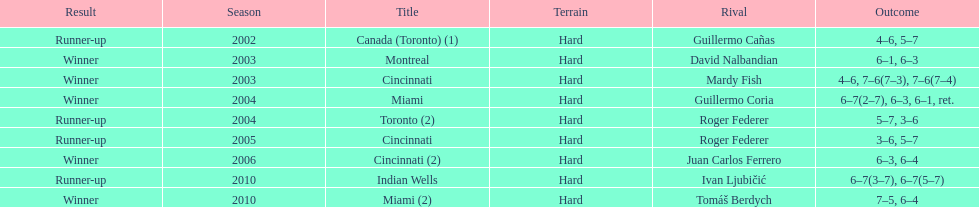How many times was the championship in miami? 2. Give me the full table as a dictionary. {'header': ['Result', 'Season', 'Title', 'Terrain', 'Rival', 'Outcome'], 'rows': [['Runner-up', '2002', 'Canada (Toronto) (1)', 'Hard', 'Guillermo Cañas', '4–6, 5–7'], ['Winner', '2003', 'Montreal', 'Hard', 'David Nalbandian', '6–1, 6–3'], ['Winner', '2003', 'Cincinnati', 'Hard', 'Mardy Fish', '4–6, 7–6(7–3), 7–6(7–4)'], ['Winner', '2004', 'Miami', 'Hard', 'Guillermo Coria', '6–7(2–7), 6–3, 6–1, ret.'], ['Runner-up', '2004', 'Toronto (2)', 'Hard', 'Roger Federer', '5–7, 3–6'], ['Runner-up', '2005', 'Cincinnati', 'Hard', 'Roger Federer', '3–6, 5–7'], ['Winner', '2006', 'Cincinnati (2)', 'Hard', 'Juan Carlos Ferrero', '6–3, 6–4'], ['Runner-up', '2010', 'Indian Wells', 'Hard', 'Ivan Ljubičić', '6–7(3–7), 6–7(5–7)'], ['Winner', '2010', 'Miami (2)', 'Hard', 'Tomáš Berdych', '7–5, 6–4']]} 